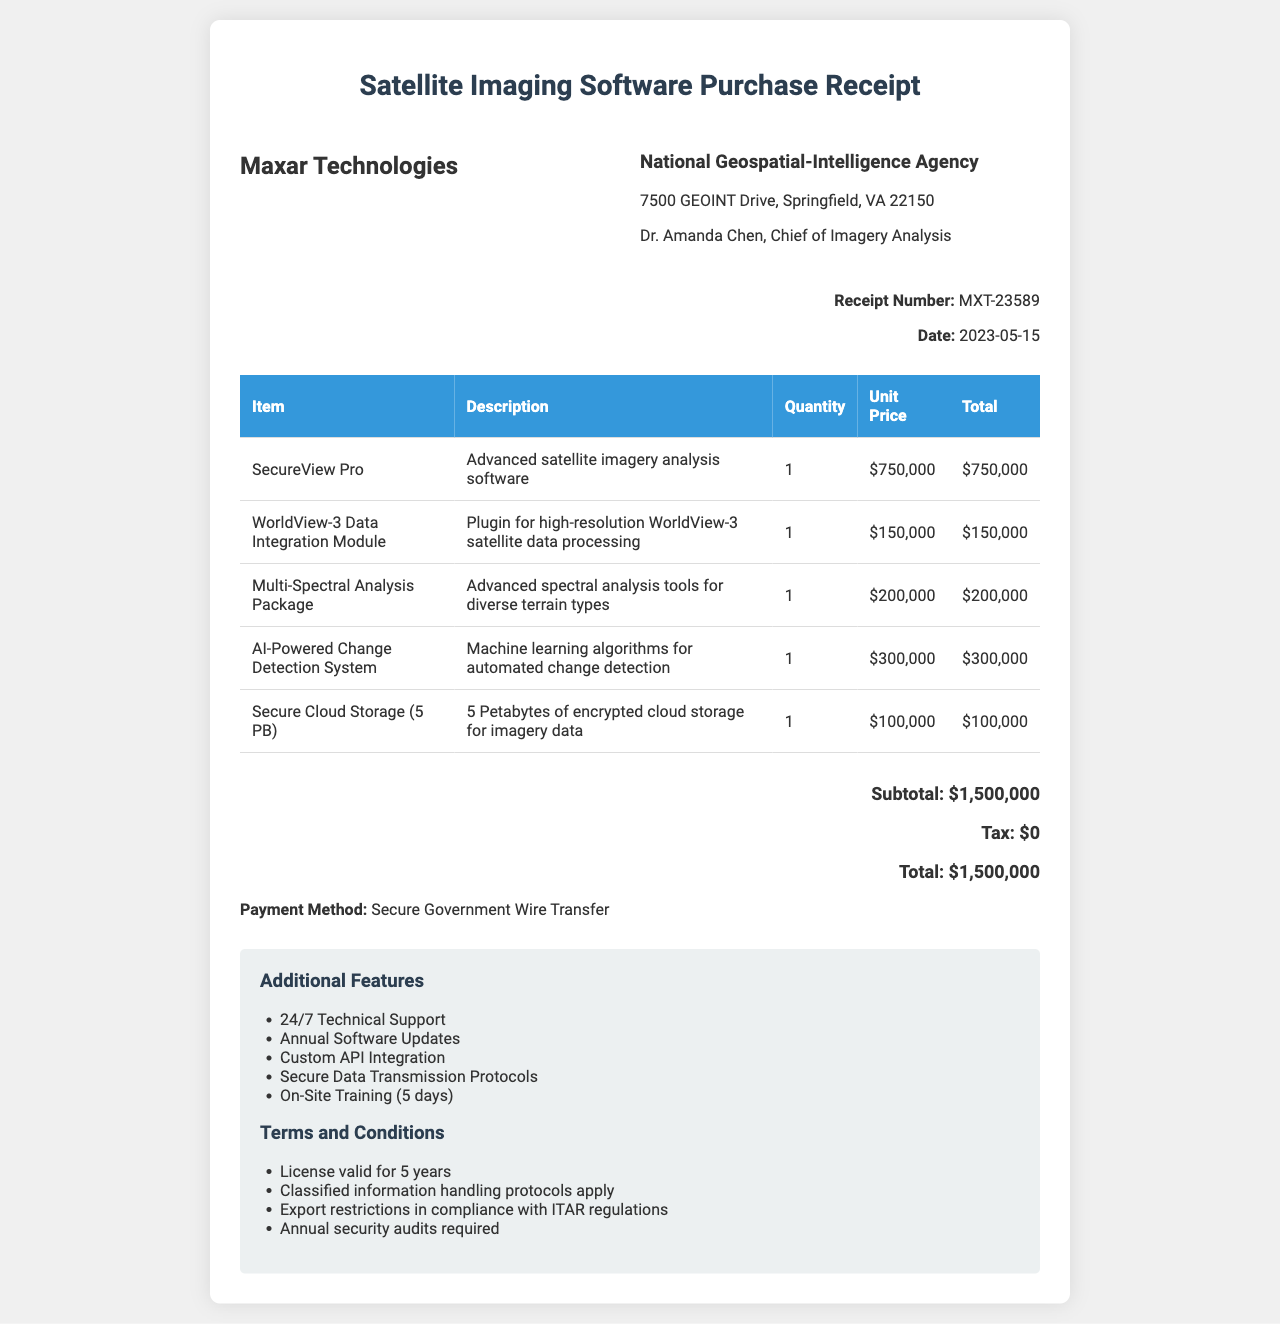What is the company name on the receipt? The company name is listed at the top of the receipt.
Answer: Maxar Technologies What is the total price of the purchased items? The total price is displayed near the bottom of the receipt.
Answer: $1,500,000 Who is the contact person from the buyer's agency? The contact person's name is provided in the buyer's information section.
Answer: Dr. Amanda Chen, Chief of Imagery Analysis How many additional features are listed in the receipt? The additional features are enumerated in a dedicated section of the receipt.
Answer: 5 What is the payment method used for this purchase? The payment method is stated clearly on the receipt.
Answer: Secure Government Wire Transfer What is the license validity period for the software? The terms and conditions specify the validity period of the license.
Answer: 5 years What type of analysis does the Multi-Spectral Analysis Package provide? The description of this item specifies the type of analysis it provides.
Answer: Advanced spectral analysis tools How much does the AI-Powered Change Detection System cost? The unit price of the AI-Powered Change Detection System can be found in the items table.
Answer: $300,000 What is the quantity of Secure Cloud Storage purchased? The quantity is indicated in the items section of the receipt.
Answer: 1 